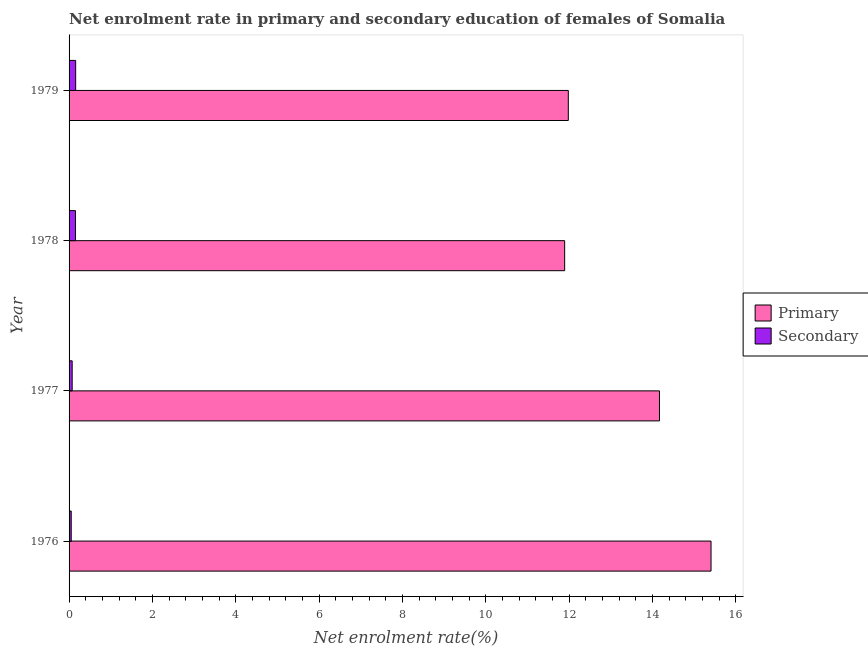How many groups of bars are there?
Your answer should be very brief. 4. Are the number of bars per tick equal to the number of legend labels?
Offer a very short reply. Yes. Are the number of bars on each tick of the Y-axis equal?
Your answer should be compact. Yes. How many bars are there on the 3rd tick from the top?
Provide a short and direct response. 2. How many bars are there on the 2nd tick from the bottom?
Provide a short and direct response. 2. What is the label of the 2nd group of bars from the top?
Your response must be concise. 1978. What is the enrollment rate in secondary education in 1978?
Make the answer very short. 0.15. Across all years, what is the maximum enrollment rate in secondary education?
Offer a terse response. 0.16. Across all years, what is the minimum enrollment rate in secondary education?
Keep it short and to the point. 0.05. In which year was the enrollment rate in primary education maximum?
Your answer should be very brief. 1976. In which year was the enrollment rate in primary education minimum?
Offer a terse response. 1978. What is the total enrollment rate in secondary education in the graph?
Offer a very short reply. 0.44. What is the difference between the enrollment rate in primary education in 1976 and that in 1978?
Your answer should be very brief. 3.51. What is the difference between the enrollment rate in secondary education in 1976 and the enrollment rate in primary education in 1979?
Provide a succinct answer. -11.93. What is the average enrollment rate in secondary education per year?
Give a very brief answer. 0.11. In the year 1979, what is the difference between the enrollment rate in primary education and enrollment rate in secondary education?
Ensure brevity in your answer.  11.82. In how many years, is the enrollment rate in primary education greater than 7.2 %?
Your answer should be compact. 4. What is the ratio of the enrollment rate in primary education in 1977 to that in 1979?
Ensure brevity in your answer.  1.18. Is the difference between the enrollment rate in primary education in 1977 and 1979 greater than the difference between the enrollment rate in secondary education in 1977 and 1979?
Your response must be concise. Yes. What is the difference between the highest and the second highest enrollment rate in secondary education?
Your response must be concise. 0. What is the difference between the highest and the lowest enrollment rate in secondary education?
Your response must be concise. 0.11. What does the 1st bar from the top in 1978 represents?
Provide a succinct answer. Secondary. What does the 2nd bar from the bottom in 1977 represents?
Your answer should be very brief. Secondary. How many bars are there?
Make the answer very short. 8. Are all the bars in the graph horizontal?
Your response must be concise. Yes. How many years are there in the graph?
Offer a terse response. 4. Does the graph contain any zero values?
Provide a short and direct response. No. Does the graph contain grids?
Your response must be concise. No. How many legend labels are there?
Ensure brevity in your answer.  2. What is the title of the graph?
Your response must be concise. Net enrolment rate in primary and secondary education of females of Somalia. What is the label or title of the X-axis?
Provide a short and direct response. Net enrolment rate(%). What is the Net enrolment rate(%) in Primary in 1976?
Keep it short and to the point. 15.4. What is the Net enrolment rate(%) of Secondary in 1976?
Keep it short and to the point. 0.05. What is the Net enrolment rate(%) in Primary in 1977?
Ensure brevity in your answer.  14.17. What is the Net enrolment rate(%) in Secondary in 1977?
Keep it short and to the point. 0.07. What is the Net enrolment rate(%) of Primary in 1978?
Make the answer very short. 11.89. What is the Net enrolment rate(%) in Secondary in 1978?
Offer a very short reply. 0.15. What is the Net enrolment rate(%) of Primary in 1979?
Provide a succinct answer. 11.98. What is the Net enrolment rate(%) of Secondary in 1979?
Provide a short and direct response. 0.16. Across all years, what is the maximum Net enrolment rate(%) of Primary?
Make the answer very short. 15.4. Across all years, what is the maximum Net enrolment rate(%) of Secondary?
Provide a short and direct response. 0.16. Across all years, what is the minimum Net enrolment rate(%) in Primary?
Give a very brief answer. 11.89. Across all years, what is the minimum Net enrolment rate(%) of Secondary?
Your answer should be compact. 0.05. What is the total Net enrolment rate(%) of Primary in the graph?
Make the answer very short. 53.44. What is the total Net enrolment rate(%) in Secondary in the graph?
Make the answer very short. 0.44. What is the difference between the Net enrolment rate(%) in Primary in 1976 and that in 1977?
Offer a very short reply. 1.24. What is the difference between the Net enrolment rate(%) of Secondary in 1976 and that in 1977?
Make the answer very short. -0.02. What is the difference between the Net enrolment rate(%) of Primary in 1976 and that in 1978?
Provide a short and direct response. 3.51. What is the difference between the Net enrolment rate(%) in Secondary in 1976 and that in 1978?
Give a very brief answer. -0.1. What is the difference between the Net enrolment rate(%) of Primary in 1976 and that in 1979?
Give a very brief answer. 3.42. What is the difference between the Net enrolment rate(%) in Secondary in 1976 and that in 1979?
Provide a short and direct response. -0.11. What is the difference between the Net enrolment rate(%) in Primary in 1977 and that in 1978?
Offer a very short reply. 2.28. What is the difference between the Net enrolment rate(%) in Secondary in 1977 and that in 1978?
Your response must be concise. -0.08. What is the difference between the Net enrolment rate(%) in Primary in 1977 and that in 1979?
Keep it short and to the point. 2.19. What is the difference between the Net enrolment rate(%) in Secondary in 1977 and that in 1979?
Your answer should be very brief. -0.08. What is the difference between the Net enrolment rate(%) of Primary in 1978 and that in 1979?
Offer a terse response. -0.09. What is the difference between the Net enrolment rate(%) of Secondary in 1978 and that in 1979?
Give a very brief answer. -0. What is the difference between the Net enrolment rate(%) of Primary in 1976 and the Net enrolment rate(%) of Secondary in 1977?
Make the answer very short. 15.33. What is the difference between the Net enrolment rate(%) of Primary in 1976 and the Net enrolment rate(%) of Secondary in 1978?
Give a very brief answer. 15.25. What is the difference between the Net enrolment rate(%) in Primary in 1976 and the Net enrolment rate(%) in Secondary in 1979?
Offer a very short reply. 15.24. What is the difference between the Net enrolment rate(%) in Primary in 1977 and the Net enrolment rate(%) in Secondary in 1978?
Keep it short and to the point. 14.01. What is the difference between the Net enrolment rate(%) in Primary in 1977 and the Net enrolment rate(%) in Secondary in 1979?
Offer a terse response. 14.01. What is the difference between the Net enrolment rate(%) in Primary in 1978 and the Net enrolment rate(%) in Secondary in 1979?
Offer a very short reply. 11.73. What is the average Net enrolment rate(%) of Primary per year?
Provide a succinct answer. 13.36. What is the average Net enrolment rate(%) in Secondary per year?
Make the answer very short. 0.11. In the year 1976, what is the difference between the Net enrolment rate(%) in Primary and Net enrolment rate(%) in Secondary?
Your response must be concise. 15.35. In the year 1977, what is the difference between the Net enrolment rate(%) of Primary and Net enrolment rate(%) of Secondary?
Offer a terse response. 14.09. In the year 1978, what is the difference between the Net enrolment rate(%) in Primary and Net enrolment rate(%) in Secondary?
Offer a very short reply. 11.74. In the year 1979, what is the difference between the Net enrolment rate(%) in Primary and Net enrolment rate(%) in Secondary?
Your answer should be very brief. 11.82. What is the ratio of the Net enrolment rate(%) in Primary in 1976 to that in 1977?
Your response must be concise. 1.09. What is the ratio of the Net enrolment rate(%) of Secondary in 1976 to that in 1977?
Provide a short and direct response. 0.69. What is the ratio of the Net enrolment rate(%) of Primary in 1976 to that in 1978?
Your answer should be very brief. 1.3. What is the ratio of the Net enrolment rate(%) of Secondary in 1976 to that in 1978?
Your response must be concise. 0.33. What is the ratio of the Net enrolment rate(%) of Primary in 1976 to that in 1979?
Keep it short and to the point. 1.29. What is the ratio of the Net enrolment rate(%) of Secondary in 1976 to that in 1979?
Provide a succinct answer. 0.33. What is the ratio of the Net enrolment rate(%) in Primary in 1977 to that in 1978?
Offer a terse response. 1.19. What is the ratio of the Net enrolment rate(%) of Secondary in 1977 to that in 1978?
Provide a succinct answer. 0.48. What is the ratio of the Net enrolment rate(%) of Primary in 1977 to that in 1979?
Your response must be concise. 1.18. What is the ratio of the Net enrolment rate(%) of Secondary in 1977 to that in 1979?
Provide a short and direct response. 0.47. What is the ratio of the Net enrolment rate(%) in Secondary in 1978 to that in 1979?
Keep it short and to the point. 0.98. What is the difference between the highest and the second highest Net enrolment rate(%) in Primary?
Your answer should be compact. 1.24. What is the difference between the highest and the second highest Net enrolment rate(%) in Secondary?
Your answer should be compact. 0. What is the difference between the highest and the lowest Net enrolment rate(%) of Primary?
Your answer should be compact. 3.51. What is the difference between the highest and the lowest Net enrolment rate(%) in Secondary?
Your answer should be compact. 0.11. 